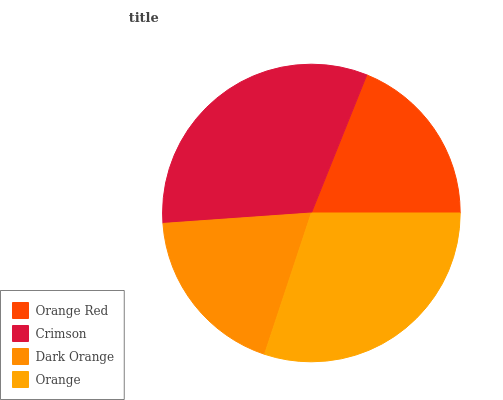Is Dark Orange the minimum?
Answer yes or no. Yes. Is Crimson the maximum?
Answer yes or no. Yes. Is Crimson the minimum?
Answer yes or no. No. Is Dark Orange the maximum?
Answer yes or no. No. Is Crimson greater than Dark Orange?
Answer yes or no. Yes. Is Dark Orange less than Crimson?
Answer yes or no. Yes. Is Dark Orange greater than Crimson?
Answer yes or no. No. Is Crimson less than Dark Orange?
Answer yes or no. No. Is Orange the high median?
Answer yes or no. Yes. Is Orange Red the low median?
Answer yes or no. Yes. Is Orange Red the high median?
Answer yes or no. No. Is Dark Orange the low median?
Answer yes or no. No. 